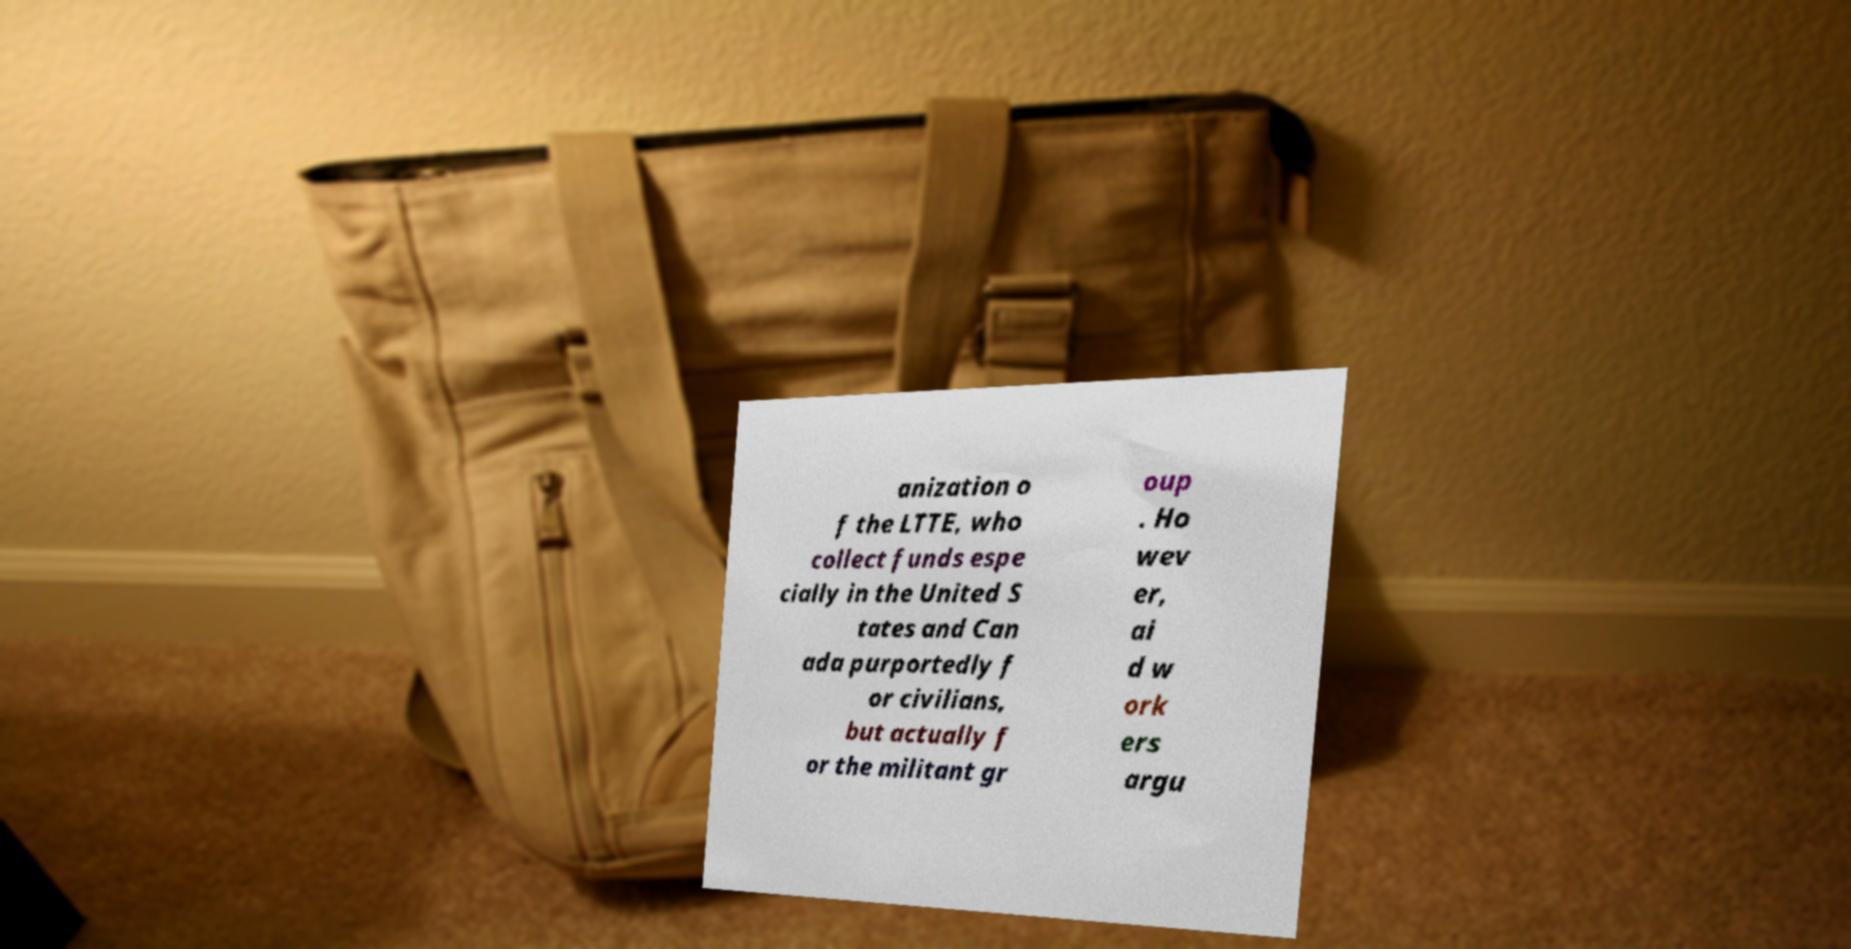Can you accurately transcribe the text from the provided image for me? anization o f the LTTE, who collect funds espe cially in the United S tates and Can ada purportedly f or civilians, but actually f or the militant gr oup . Ho wev er, ai d w ork ers argu 